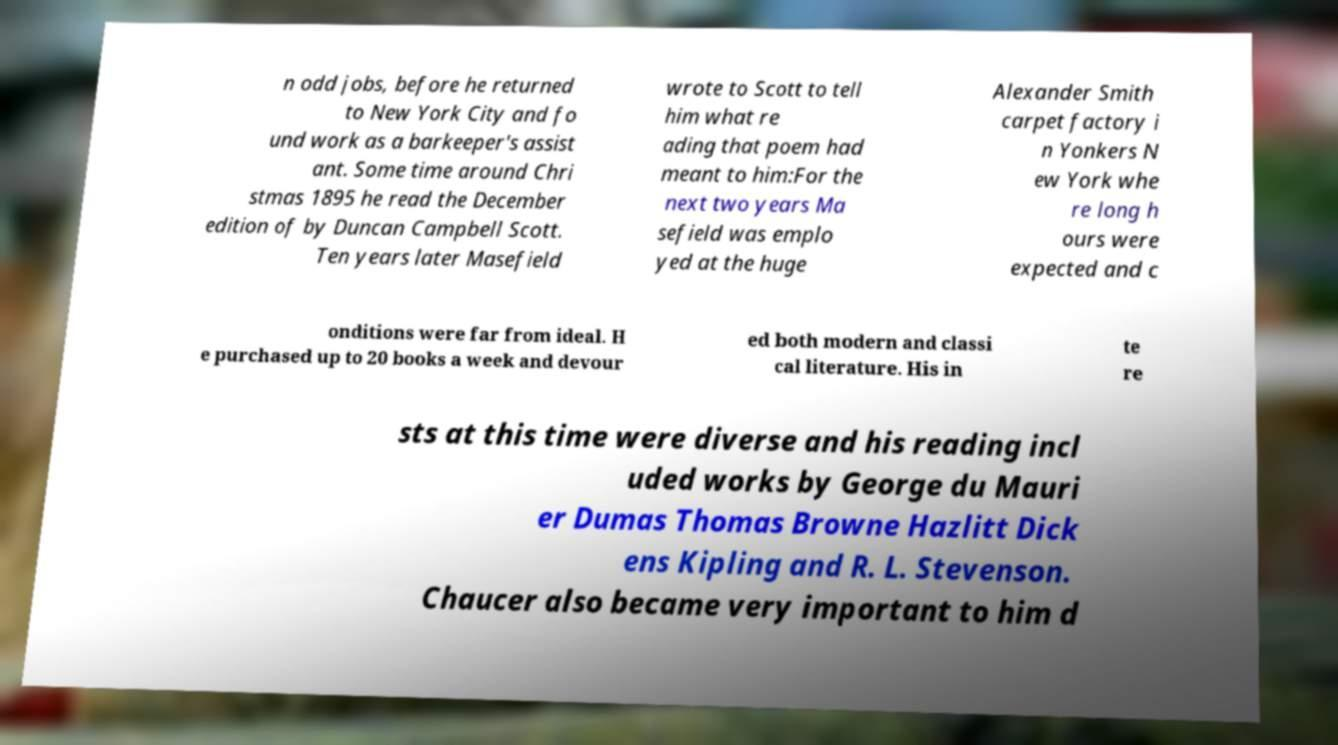Can you accurately transcribe the text from the provided image for me? n odd jobs, before he returned to New York City and fo und work as a barkeeper's assist ant. Some time around Chri stmas 1895 he read the December edition of by Duncan Campbell Scott. Ten years later Masefield wrote to Scott to tell him what re ading that poem had meant to him:For the next two years Ma sefield was emplo yed at the huge Alexander Smith carpet factory i n Yonkers N ew York whe re long h ours were expected and c onditions were far from ideal. H e purchased up to 20 books a week and devour ed both modern and classi cal literature. His in te re sts at this time were diverse and his reading incl uded works by George du Mauri er Dumas Thomas Browne Hazlitt Dick ens Kipling and R. L. Stevenson. Chaucer also became very important to him d 